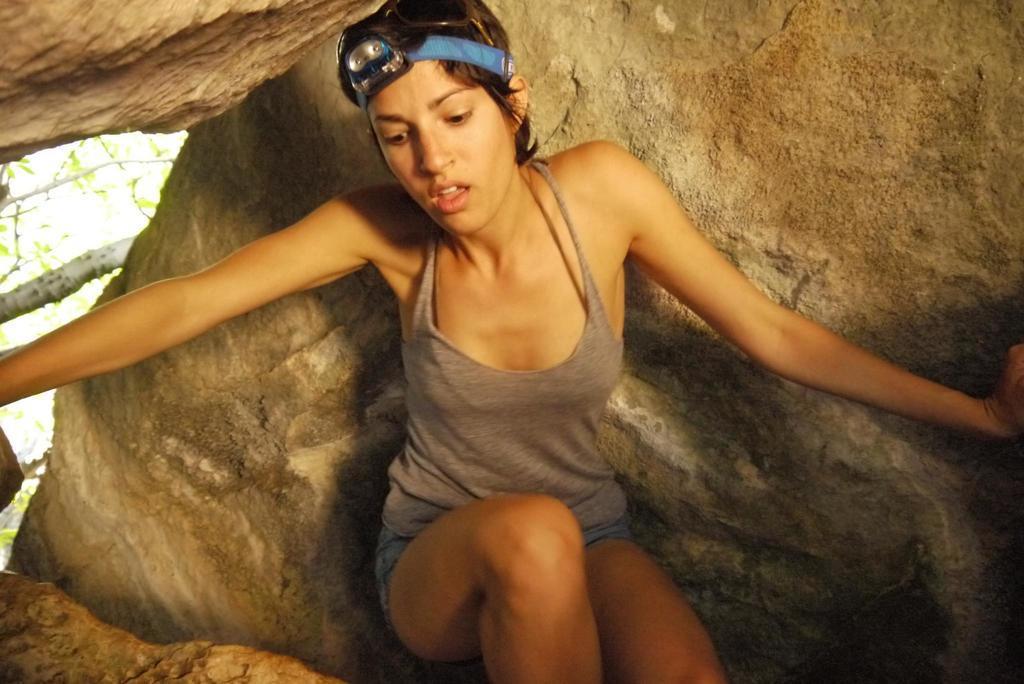In one or two sentences, can you explain what this image depicts? This image is taken outdoors. In the background there is a rock and there is a tree. In the middle of the image there is a woman. 